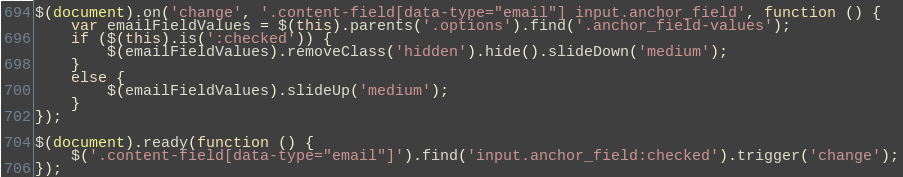<code> <loc_0><loc_0><loc_500><loc_500><_JavaScript_>$(document).on('change', '.content-field[data-type="email"] input.anchor_field', function () {
    var emailFieldValues = $(this).parents('.options').find('.anchor_field-values');
    if ($(this).is(':checked')) {
        $(emailFieldValues).removeClass('hidden').hide().slideDown('medium');
    }
    else {
        $(emailFieldValues).slideUp('medium');
    }
});

$(document).ready(function () {
    $('.content-field[data-type="email"]').find('input.anchor_field:checked').trigger('change');
});</code> 